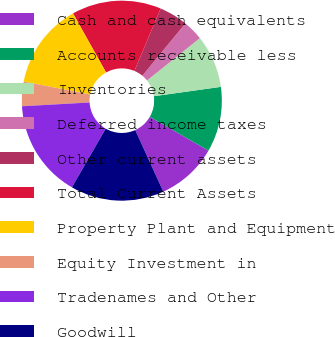<chart> <loc_0><loc_0><loc_500><loc_500><pie_chart><fcel>Cash and cash equivalents<fcel>Accounts receivable less<fcel>Inventories<fcel>Deferred income taxes<fcel>Other current assets<fcel>Total Current Assets<fcel>Property Plant and Equipment<fcel>Equity Investment in<fcel>Tradenames and Other<fcel>Goodwill<nl><fcel>9.87%<fcel>10.53%<fcel>8.55%<fcel>3.29%<fcel>4.61%<fcel>14.47%<fcel>13.82%<fcel>3.95%<fcel>15.79%<fcel>15.13%<nl></chart> 